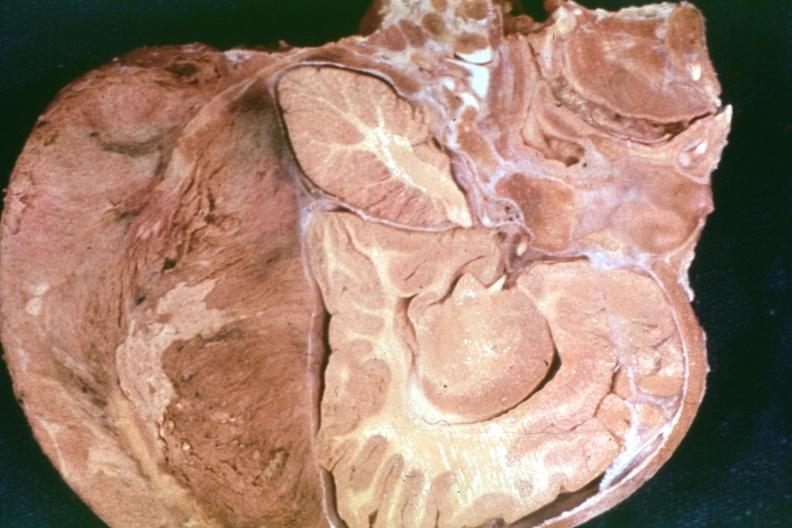what is present?
Answer the question using a single word or phrase. Bone, calvarium 